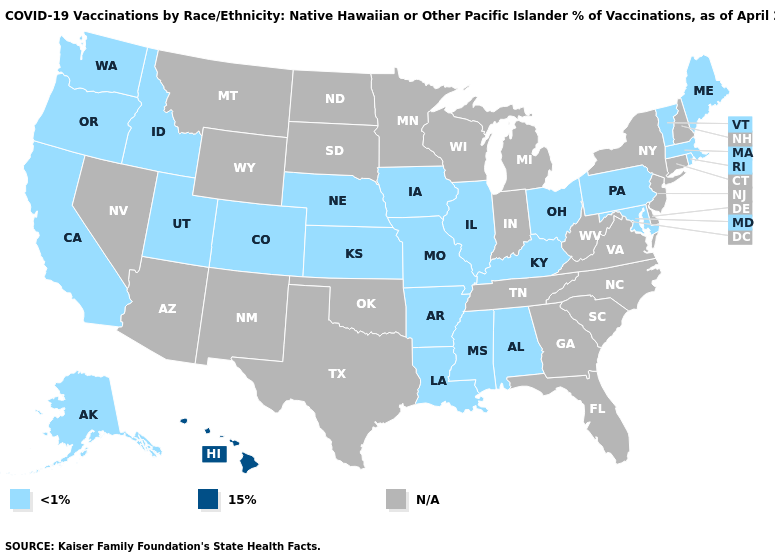What is the value of Tennessee?
Give a very brief answer. N/A. What is the highest value in the Northeast ?
Quick response, please. <1%. Which states have the highest value in the USA?
Keep it brief. Hawaii. What is the value of Nevada?
Give a very brief answer. N/A. Name the states that have a value in the range <1%?
Concise answer only. Alabama, Alaska, Arkansas, California, Colorado, Idaho, Illinois, Iowa, Kansas, Kentucky, Louisiana, Maine, Maryland, Massachusetts, Mississippi, Missouri, Nebraska, Ohio, Oregon, Pennsylvania, Rhode Island, Utah, Vermont, Washington. What is the value of Kansas?
Short answer required. <1%. What is the lowest value in the USA?
Quick response, please. <1%. Among the states that border Arkansas , which have the highest value?
Write a very short answer. Louisiana, Mississippi, Missouri. Name the states that have a value in the range 15%?
Be succinct. Hawaii. 